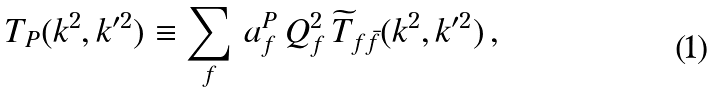Convert formula to latex. <formula><loc_0><loc_0><loc_500><loc_500>T _ { P } ( k ^ { 2 } , k ^ { \prime 2 } ) \equiv \sum _ { f } \, a _ { f } ^ { P } \, Q _ { f } ^ { 2 } \, { \widetilde { T } } _ { f \bar { f } } ( k ^ { 2 } , k ^ { \prime 2 } ) \, ,</formula> 